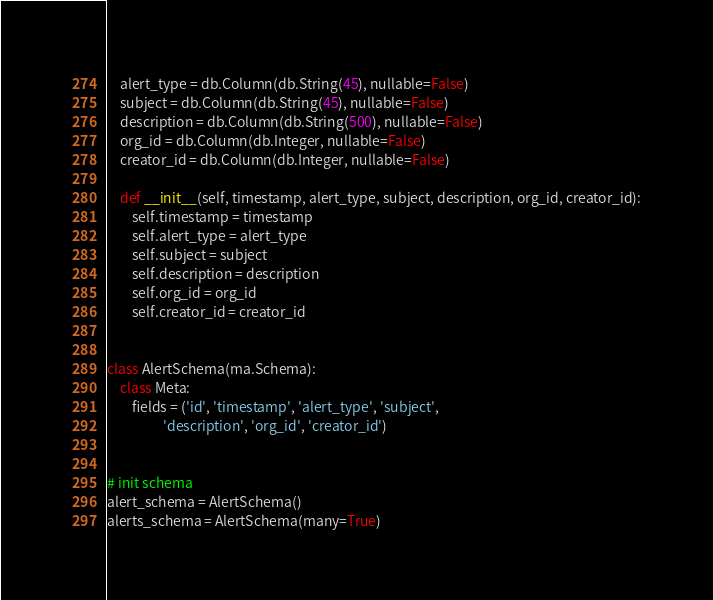Convert code to text. <code><loc_0><loc_0><loc_500><loc_500><_Python_>    alert_type = db.Column(db.String(45), nullable=False)
    subject = db.Column(db.String(45), nullable=False)
    description = db.Column(db.String(500), nullable=False)
    org_id = db.Column(db.Integer, nullable=False)
    creator_id = db.Column(db.Integer, nullable=False)

    def __init__(self, timestamp, alert_type, subject, description, org_id, creator_id):
        self.timestamp = timestamp
        self.alert_type = alert_type
        self.subject = subject
        self.description = description
        self.org_id = org_id
        self.creator_id = creator_id


class AlertSchema(ma.Schema):
    class Meta:
        fields = ('id', 'timestamp', 'alert_type', 'subject',
                  'description', 'org_id', 'creator_id')


# init schema
alert_schema = AlertSchema()
alerts_schema = AlertSchema(many=True)
</code> 